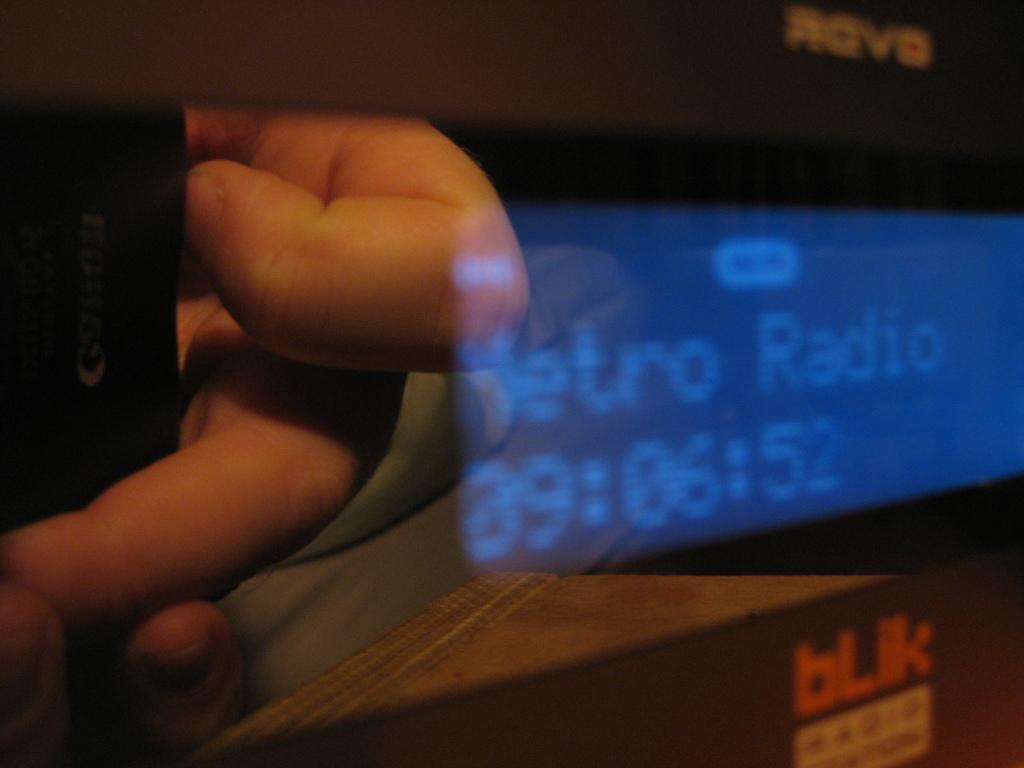Could you give a brief overview of what you see in this image? In this image there is one person's hand on the left side of this image and there is screen on the right side of this image. 